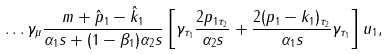Convert formula to latex. <formula><loc_0><loc_0><loc_500><loc_500>\dots \gamma _ { \mu } \frac { m + \hat { p } _ { 1 } - \hat { k } _ { 1 } } { \alpha _ { 1 } s + ( 1 - \beta _ { 1 } ) \alpha _ { 2 } s } \left [ \gamma _ { \tau _ { 1 } } \frac { 2 p _ { 1 \tau _ { 2 } } } { \alpha _ { 2 } s } + \frac { 2 ( p _ { 1 } - k _ { 1 } ) _ { \tau _ { 2 } } } { \alpha _ { 1 } s } \gamma _ { \tau _ { 1 } } \right ] u _ { 1 } ,</formula> 